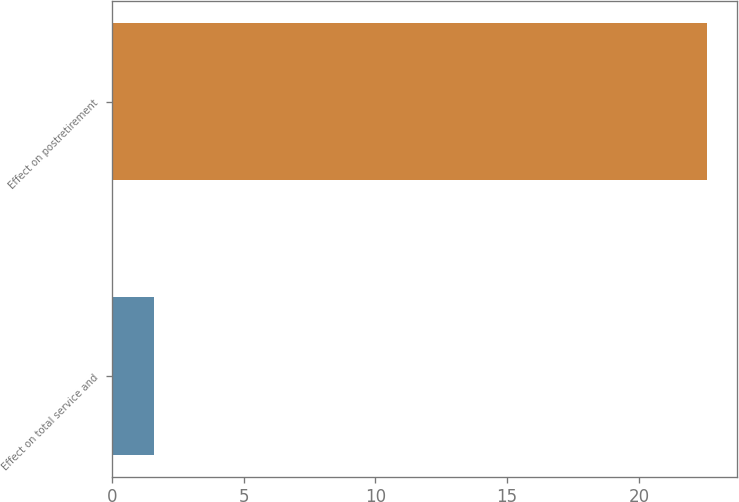<chart> <loc_0><loc_0><loc_500><loc_500><bar_chart><fcel>Effect on total service and<fcel>Effect on postretirement<nl><fcel>1.6<fcel>22.6<nl></chart> 